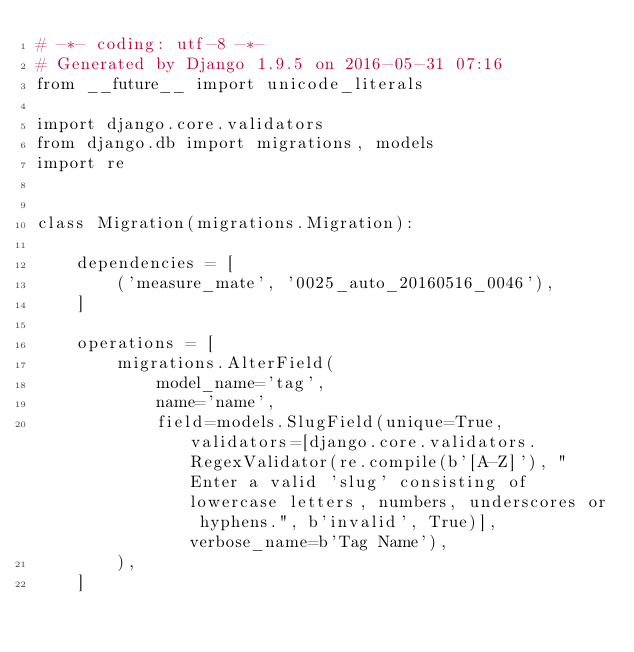<code> <loc_0><loc_0><loc_500><loc_500><_Python_># -*- coding: utf-8 -*-
# Generated by Django 1.9.5 on 2016-05-31 07:16
from __future__ import unicode_literals

import django.core.validators
from django.db import migrations, models
import re


class Migration(migrations.Migration):

    dependencies = [
        ('measure_mate', '0025_auto_20160516_0046'),
    ]

    operations = [
        migrations.AlterField(
            model_name='tag',
            name='name',
            field=models.SlugField(unique=True, validators=[django.core.validators.RegexValidator(re.compile(b'[A-Z]'), "Enter a valid 'slug' consisting of lowercase letters, numbers, underscores or hyphens.", b'invalid', True)], verbose_name=b'Tag Name'),
        ),
    ]
</code> 